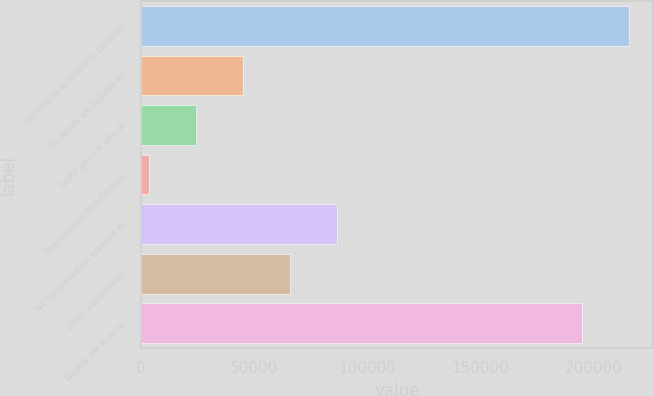Convert chart. <chart><loc_0><loc_0><loc_500><loc_500><bar_chart><fcel>Net income available to common<fcel>Dividends attributable to<fcel>GAAP gain on sale of<fcel>Depreciation/Amortization<fcel>Tax compensation expense in<fcel>Other adjustments<fcel>Taxable net income<nl><fcel>215389<fcel>45243.4<fcel>24518.2<fcel>3793<fcel>86693.8<fcel>65968.6<fcel>194664<nl></chart> 